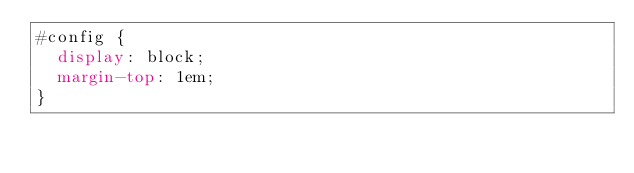<code> <loc_0><loc_0><loc_500><loc_500><_CSS_>#config {
  display: block;
  margin-top: 1em;
}
</code> 